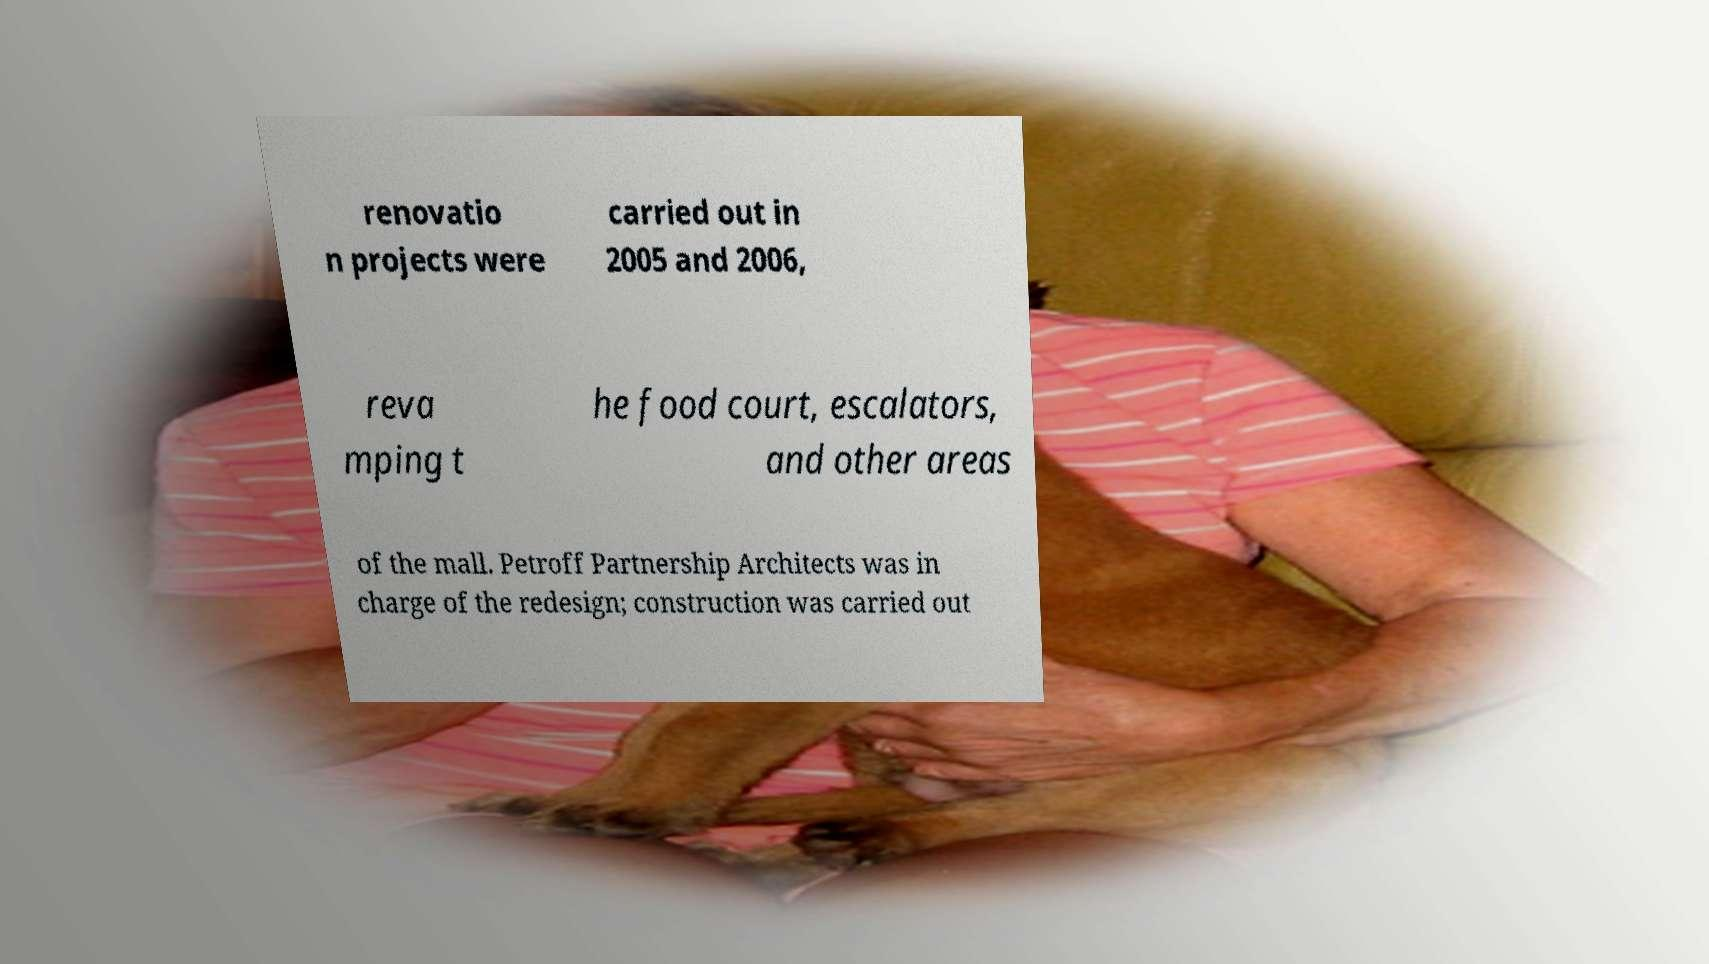I need the written content from this picture converted into text. Can you do that? renovatio n projects were carried out in 2005 and 2006, reva mping t he food court, escalators, and other areas of the mall. Petroff Partnership Architects was in charge of the redesign; construction was carried out 